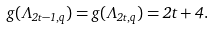Convert formula to latex. <formula><loc_0><loc_0><loc_500><loc_500>g ( \Lambda _ { 2 t - 1 , q } ) = g ( \Lambda _ { 2 t , q } ) = 2 t + 4 .</formula> 